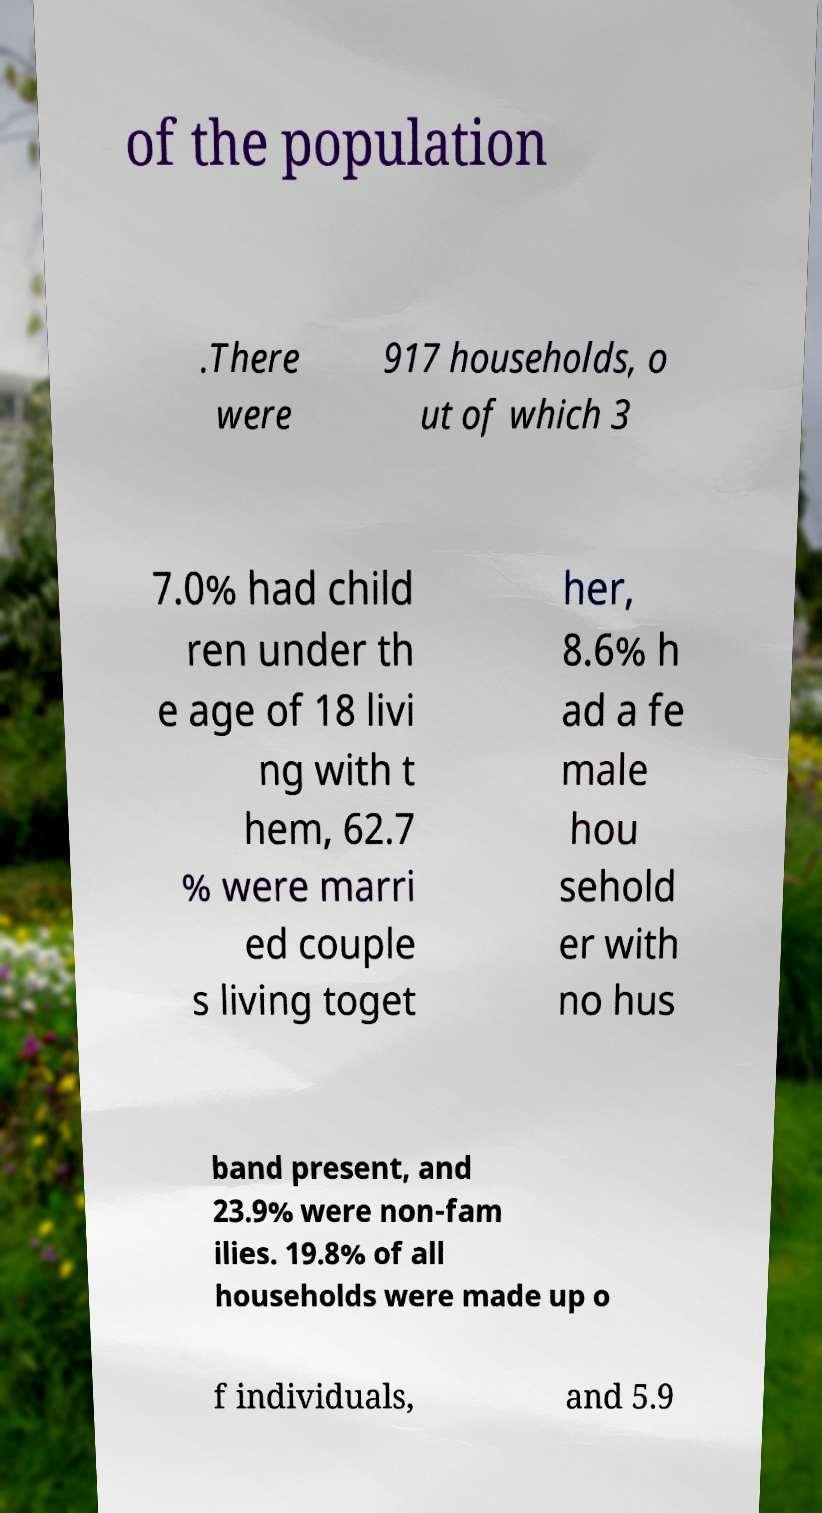Could you extract and type out the text from this image? of the population .There were 917 households, o ut of which 3 7.0% had child ren under th e age of 18 livi ng with t hem, 62.7 % were marri ed couple s living toget her, 8.6% h ad a fe male hou sehold er with no hus band present, and 23.9% were non-fam ilies. 19.8% of all households were made up o f individuals, and 5.9 